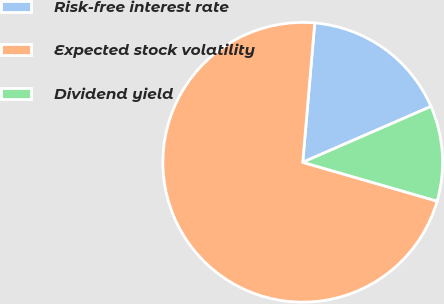<chart> <loc_0><loc_0><loc_500><loc_500><pie_chart><fcel>Risk-free interest rate<fcel>Expected stock volatility<fcel>Dividend yield<nl><fcel>17.1%<fcel>71.89%<fcel>11.01%<nl></chart> 